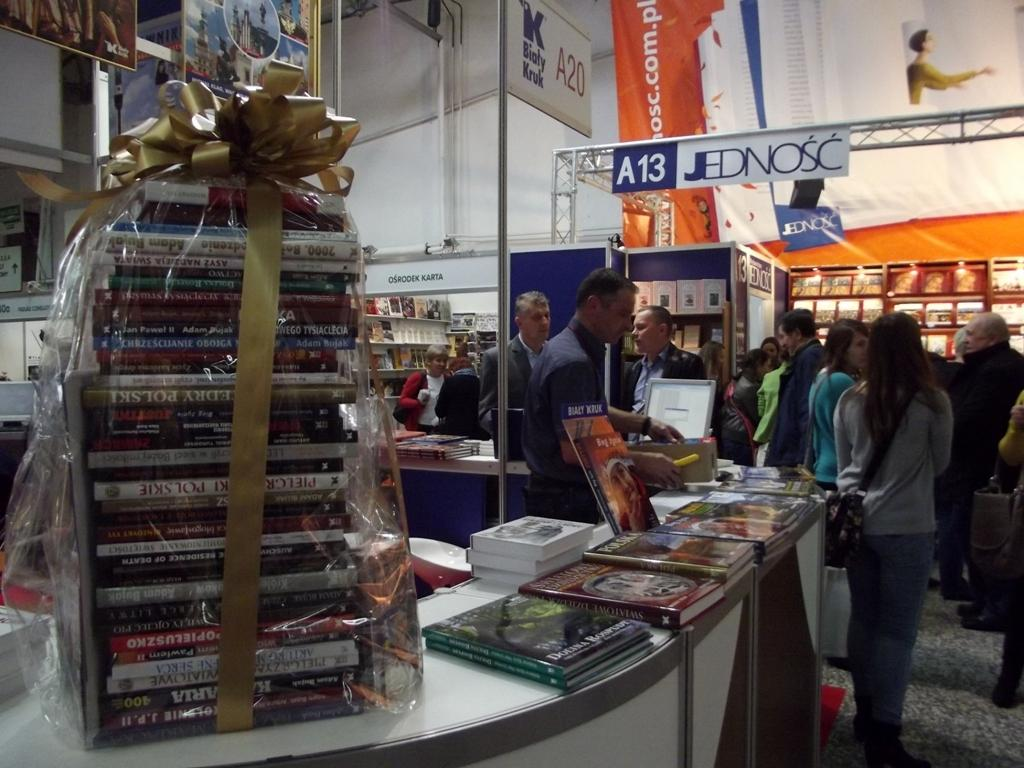<image>
Write a terse but informative summary of the picture. At a trade show, booth A13 is for Jednosc. 